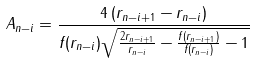Convert formula to latex. <formula><loc_0><loc_0><loc_500><loc_500>A _ { n - i } = \frac { 4 \, ( r _ { n - i + 1 } - r _ { n - i } ) } { f ( r _ { n - i } ) \sqrt { \frac { 2 r _ { n - i + 1 } } { r _ { n - i } } - \frac { f ( r _ { n - i + 1 } ) } { f ( r _ { n - i } ) } - 1 } }</formula> 